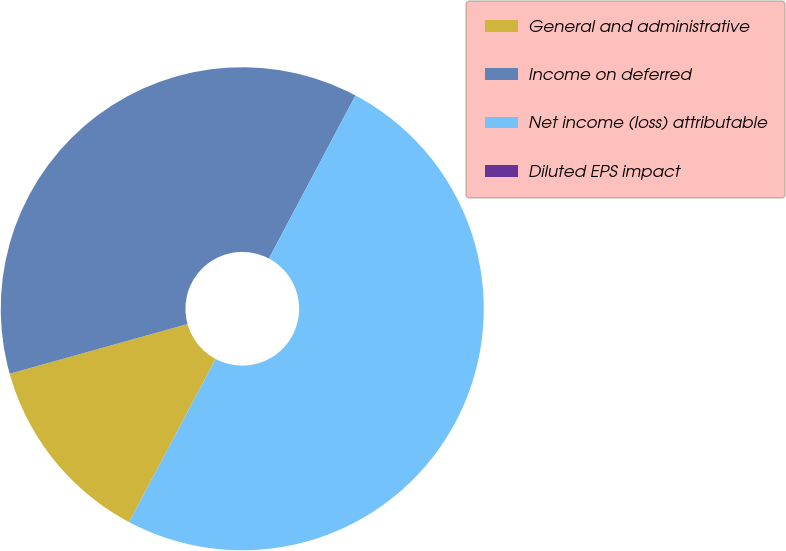Convert chart. <chart><loc_0><loc_0><loc_500><loc_500><pie_chart><fcel>General and administrative<fcel>Income on deferred<fcel>Net income (loss) attributable<fcel>Diluted EPS impact<nl><fcel>12.9%<fcel>37.1%<fcel>50.0%<fcel>0.0%<nl></chart> 